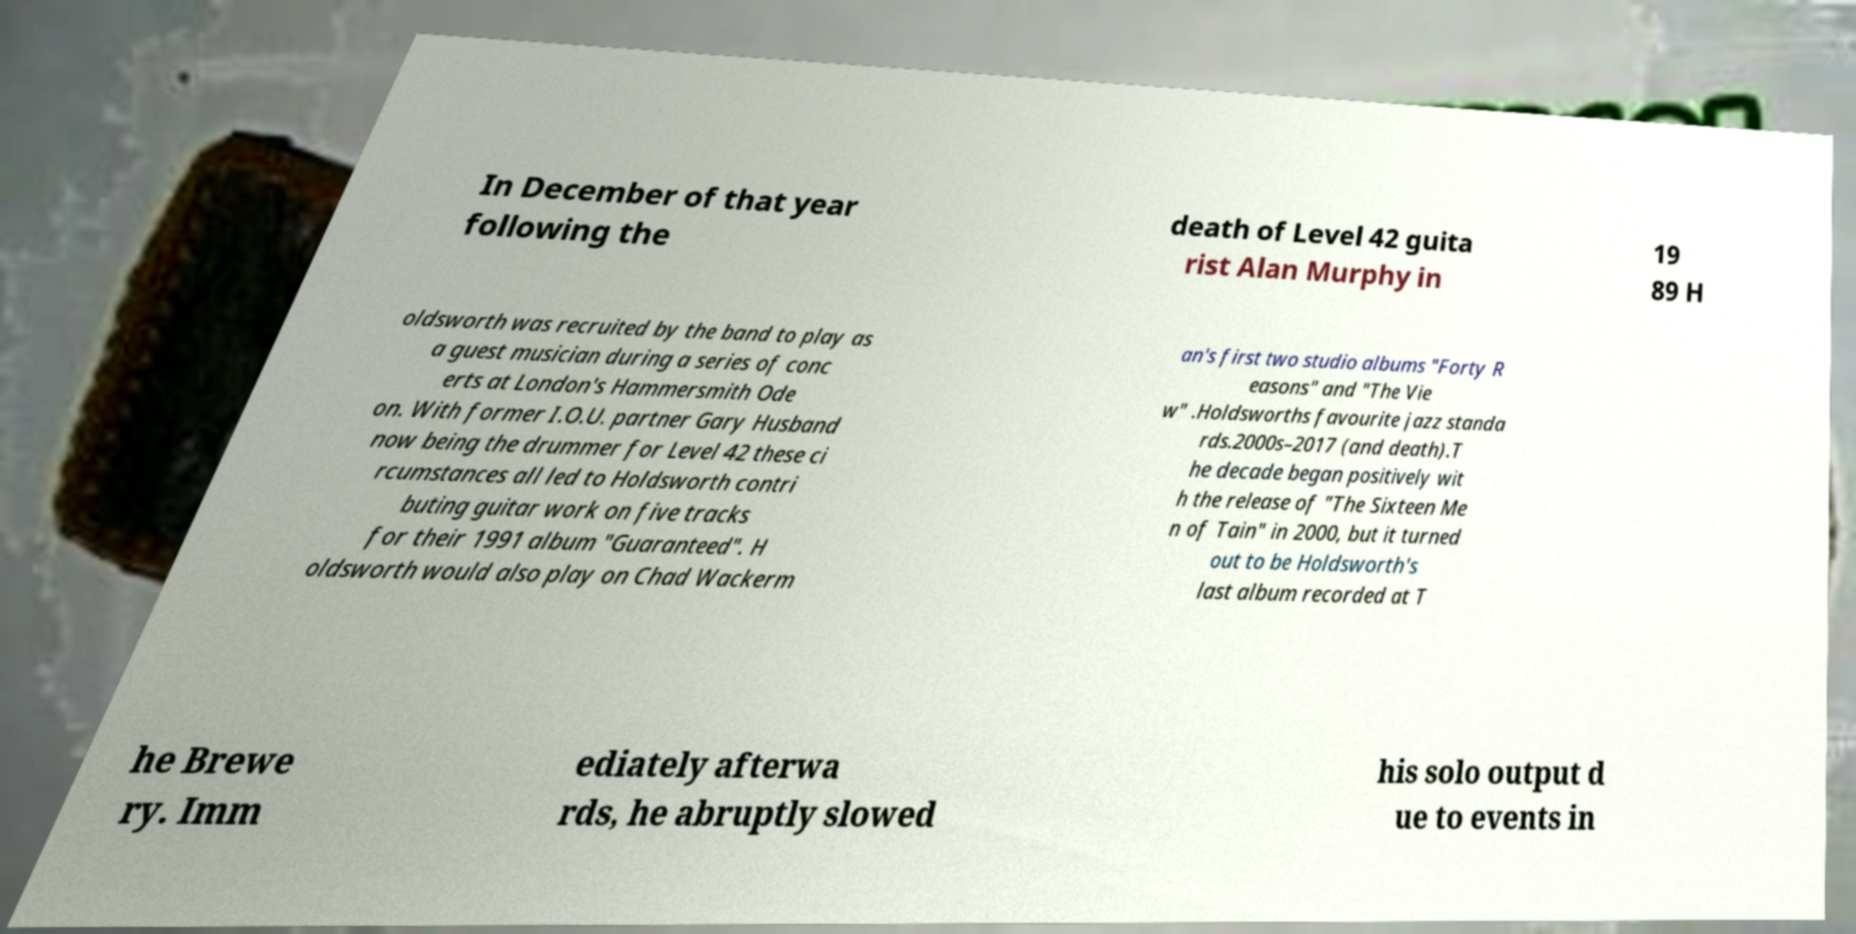I need the written content from this picture converted into text. Can you do that? In December of that year following the death of Level 42 guita rist Alan Murphy in 19 89 H oldsworth was recruited by the band to play as a guest musician during a series of conc erts at London's Hammersmith Ode on. With former I.O.U. partner Gary Husband now being the drummer for Level 42 these ci rcumstances all led to Holdsworth contri buting guitar work on five tracks for their 1991 album "Guaranteed". H oldsworth would also play on Chad Wackerm an's first two studio albums "Forty R easons" and "The Vie w" .Holdsworths favourite jazz standa rds.2000s–2017 (and death).T he decade began positively wit h the release of "The Sixteen Me n of Tain" in 2000, but it turned out to be Holdsworth's last album recorded at T he Brewe ry. Imm ediately afterwa rds, he abruptly slowed his solo output d ue to events in 